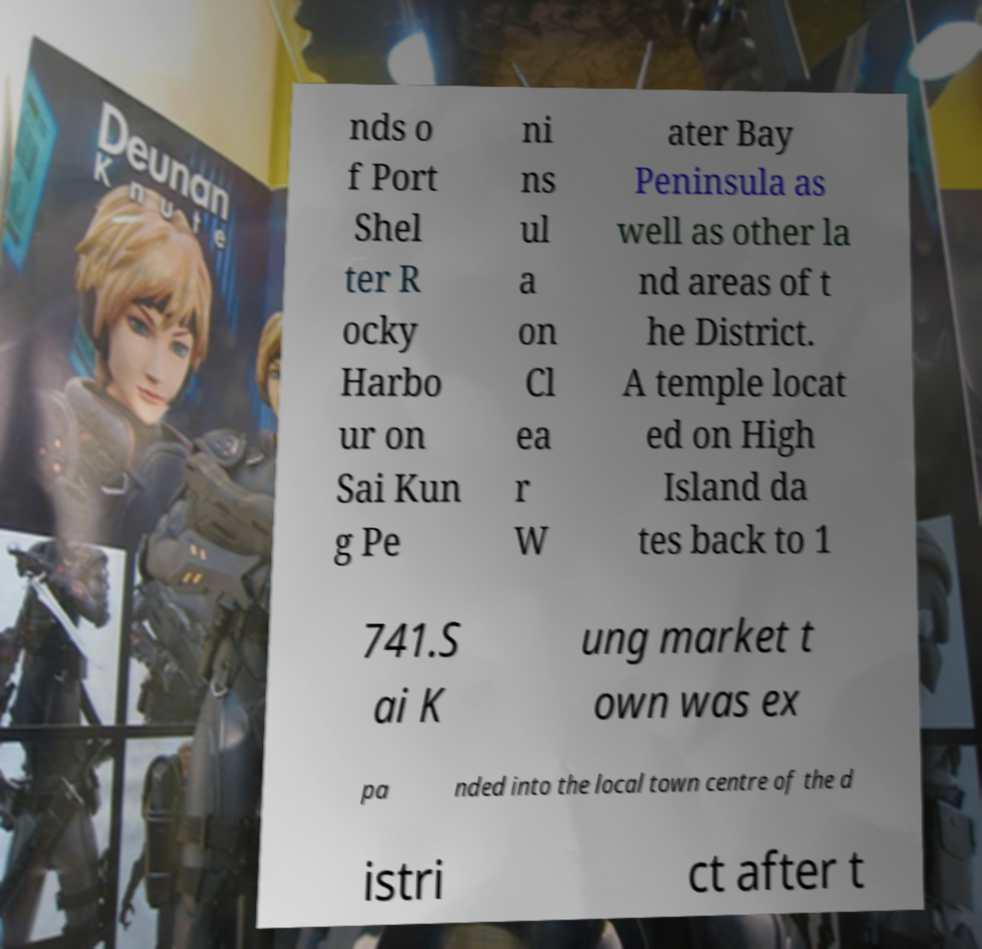I need the written content from this picture converted into text. Can you do that? nds o f Port Shel ter R ocky Harbo ur on Sai Kun g Pe ni ns ul a on Cl ea r W ater Bay Peninsula as well as other la nd areas of t he District. A temple locat ed on High Island da tes back to 1 741.S ai K ung market t own was ex pa nded into the local town centre of the d istri ct after t 